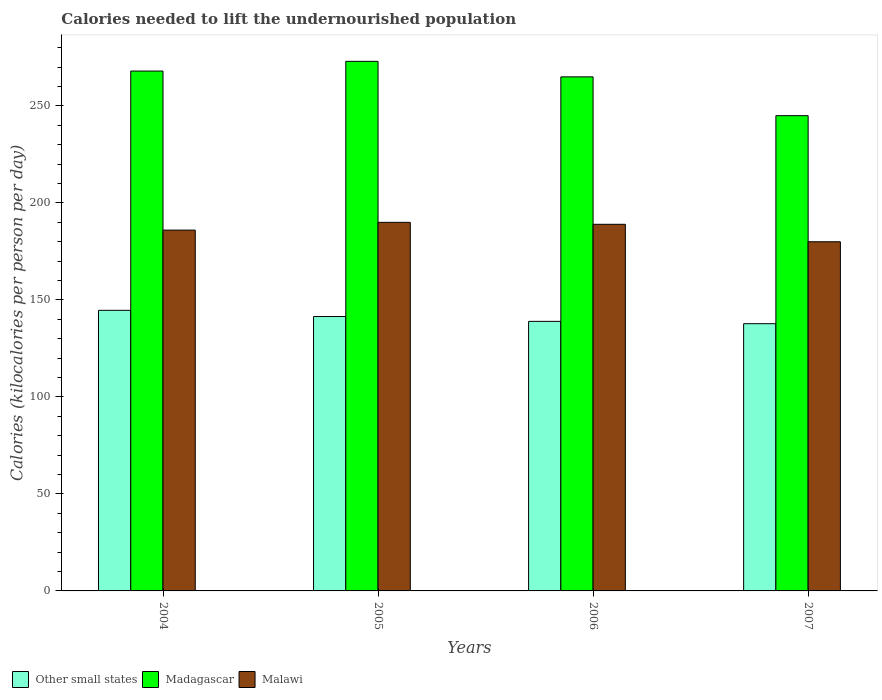What is the label of the 1st group of bars from the left?
Your response must be concise. 2004. What is the total calories needed to lift the undernourished population in Malawi in 2007?
Your response must be concise. 180. Across all years, what is the maximum total calories needed to lift the undernourished population in Other small states?
Keep it short and to the point. 144.65. Across all years, what is the minimum total calories needed to lift the undernourished population in Other small states?
Your answer should be very brief. 137.76. In which year was the total calories needed to lift the undernourished population in Madagascar maximum?
Provide a succinct answer. 2005. What is the total total calories needed to lift the undernourished population in Other small states in the graph?
Make the answer very short. 562.81. What is the difference between the total calories needed to lift the undernourished population in Other small states in 2005 and that in 2007?
Ensure brevity in your answer.  3.69. What is the difference between the total calories needed to lift the undernourished population in Madagascar in 2007 and the total calories needed to lift the undernourished population in Other small states in 2005?
Keep it short and to the point. 103.55. What is the average total calories needed to lift the undernourished population in Madagascar per year?
Provide a short and direct response. 262.75. In the year 2006, what is the difference between the total calories needed to lift the undernourished population in Madagascar and total calories needed to lift the undernourished population in Malawi?
Provide a short and direct response. 76. What is the ratio of the total calories needed to lift the undernourished population in Other small states in 2005 to that in 2006?
Your answer should be compact. 1.02. Is the total calories needed to lift the undernourished population in Other small states in 2004 less than that in 2006?
Offer a terse response. No. What is the difference between the highest and the second highest total calories needed to lift the undernourished population in Malawi?
Ensure brevity in your answer.  1. What is the difference between the highest and the lowest total calories needed to lift the undernourished population in Other small states?
Your response must be concise. 6.88. Is the sum of the total calories needed to lift the undernourished population in Other small states in 2005 and 2007 greater than the maximum total calories needed to lift the undernourished population in Madagascar across all years?
Your answer should be very brief. Yes. What does the 1st bar from the left in 2007 represents?
Your answer should be compact. Other small states. What does the 3rd bar from the right in 2006 represents?
Keep it short and to the point. Other small states. Are all the bars in the graph horizontal?
Provide a short and direct response. No. Does the graph contain any zero values?
Your answer should be compact. No. Where does the legend appear in the graph?
Keep it short and to the point. Bottom left. How many legend labels are there?
Ensure brevity in your answer.  3. How are the legend labels stacked?
Offer a terse response. Horizontal. What is the title of the graph?
Give a very brief answer. Calories needed to lift the undernourished population. What is the label or title of the X-axis?
Your response must be concise. Years. What is the label or title of the Y-axis?
Keep it short and to the point. Calories (kilocalories per person per day). What is the Calories (kilocalories per person per day) of Other small states in 2004?
Give a very brief answer. 144.65. What is the Calories (kilocalories per person per day) in Madagascar in 2004?
Provide a short and direct response. 268. What is the Calories (kilocalories per person per day) of Malawi in 2004?
Your answer should be very brief. 186. What is the Calories (kilocalories per person per day) in Other small states in 2005?
Offer a terse response. 141.45. What is the Calories (kilocalories per person per day) of Madagascar in 2005?
Give a very brief answer. 273. What is the Calories (kilocalories per person per day) of Malawi in 2005?
Ensure brevity in your answer.  190. What is the Calories (kilocalories per person per day) in Other small states in 2006?
Ensure brevity in your answer.  138.96. What is the Calories (kilocalories per person per day) in Madagascar in 2006?
Your answer should be very brief. 265. What is the Calories (kilocalories per person per day) of Malawi in 2006?
Your answer should be compact. 189. What is the Calories (kilocalories per person per day) of Other small states in 2007?
Make the answer very short. 137.76. What is the Calories (kilocalories per person per day) in Madagascar in 2007?
Your answer should be very brief. 245. What is the Calories (kilocalories per person per day) in Malawi in 2007?
Make the answer very short. 180. Across all years, what is the maximum Calories (kilocalories per person per day) in Other small states?
Your response must be concise. 144.65. Across all years, what is the maximum Calories (kilocalories per person per day) of Madagascar?
Your response must be concise. 273. Across all years, what is the maximum Calories (kilocalories per person per day) of Malawi?
Offer a terse response. 190. Across all years, what is the minimum Calories (kilocalories per person per day) of Other small states?
Give a very brief answer. 137.76. Across all years, what is the minimum Calories (kilocalories per person per day) of Madagascar?
Provide a short and direct response. 245. Across all years, what is the minimum Calories (kilocalories per person per day) of Malawi?
Provide a short and direct response. 180. What is the total Calories (kilocalories per person per day) of Other small states in the graph?
Your response must be concise. 562.81. What is the total Calories (kilocalories per person per day) in Madagascar in the graph?
Offer a very short reply. 1051. What is the total Calories (kilocalories per person per day) of Malawi in the graph?
Offer a very short reply. 745. What is the difference between the Calories (kilocalories per person per day) in Other small states in 2004 and that in 2005?
Give a very brief answer. 3.2. What is the difference between the Calories (kilocalories per person per day) of Madagascar in 2004 and that in 2005?
Make the answer very short. -5. What is the difference between the Calories (kilocalories per person per day) of Other small states in 2004 and that in 2006?
Offer a terse response. 5.69. What is the difference between the Calories (kilocalories per person per day) in Other small states in 2004 and that in 2007?
Make the answer very short. 6.88. What is the difference between the Calories (kilocalories per person per day) in Madagascar in 2004 and that in 2007?
Give a very brief answer. 23. What is the difference between the Calories (kilocalories per person per day) of Malawi in 2004 and that in 2007?
Your answer should be compact. 6. What is the difference between the Calories (kilocalories per person per day) of Other small states in 2005 and that in 2006?
Offer a terse response. 2.49. What is the difference between the Calories (kilocalories per person per day) in Madagascar in 2005 and that in 2006?
Offer a very short reply. 8. What is the difference between the Calories (kilocalories per person per day) in Other small states in 2005 and that in 2007?
Your response must be concise. 3.69. What is the difference between the Calories (kilocalories per person per day) of Malawi in 2005 and that in 2007?
Your response must be concise. 10. What is the difference between the Calories (kilocalories per person per day) in Other small states in 2006 and that in 2007?
Keep it short and to the point. 1.19. What is the difference between the Calories (kilocalories per person per day) in Madagascar in 2006 and that in 2007?
Provide a short and direct response. 20. What is the difference between the Calories (kilocalories per person per day) of Malawi in 2006 and that in 2007?
Keep it short and to the point. 9. What is the difference between the Calories (kilocalories per person per day) of Other small states in 2004 and the Calories (kilocalories per person per day) of Madagascar in 2005?
Give a very brief answer. -128.35. What is the difference between the Calories (kilocalories per person per day) of Other small states in 2004 and the Calories (kilocalories per person per day) of Malawi in 2005?
Offer a very short reply. -45.35. What is the difference between the Calories (kilocalories per person per day) in Madagascar in 2004 and the Calories (kilocalories per person per day) in Malawi in 2005?
Your answer should be compact. 78. What is the difference between the Calories (kilocalories per person per day) of Other small states in 2004 and the Calories (kilocalories per person per day) of Madagascar in 2006?
Your answer should be very brief. -120.35. What is the difference between the Calories (kilocalories per person per day) in Other small states in 2004 and the Calories (kilocalories per person per day) in Malawi in 2006?
Your answer should be very brief. -44.35. What is the difference between the Calories (kilocalories per person per day) in Madagascar in 2004 and the Calories (kilocalories per person per day) in Malawi in 2006?
Give a very brief answer. 79. What is the difference between the Calories (kilocalories per person per day) in Other small states in 2004 and the Calories (kilocalories per person per day) in Madagascar in 2007?
Ensure brevity in your answer.  -100.35. What is the difference between the Calories (kilocalories per person per day) in Other small states in 2004 and the Calories (kilocalories per person per day) in Malawi in 2007?
Your answer should be compact. -35.35. What is the difference between the Calories (kilocalories per person per day) in Other small states in 2005 and the Calories (kilocalories per person per day) in Madagascar in 2006?
Provide a short and direct response. -123.55. What is the difference between the Calories (kilocalories per person per day) in Other small states in 2005 and the Calories (kilocalories per person per day) in Malawi in 2006?
Make the answer very short. -47.55. What is the difference between the Calories (kilocalories per person per day) in Other small states in 2005 and the Calories (kilocalories per person per day) in Madagascar in 2007?
Your answer should be compact. -103.55. What is the difference between the Calories (kilocalories per person per day) in Other small states in 2005 and the Calories (kilocalories per person per day) in Malawi in 2007?
Ensure brevity in your answer.  -38.55. What is the difference between the Calories (kilocalories per person per day) in Madagascar in 2005 and the Calories (kilocalories per person per day) in Malawi in 2007?
Keep it short and to the point. 93. What is the difference between the Calories (kilocalories per person per day) of Other small states in 2006 and the Calories (kilocalories per person per day) of Madagascar in 2007?
Your response must be concise. -106.04. What is the difference between the Calories (kilocalories per person per day) in Other small states in 2006 and the Calories (kilocalories per person per day) in Malawi in 2007?
Keep it short and to the point. -41.04. What is the average Calories (kilocalories per person per day) in Other small states per year?
Offer a terse response. 140.7. What is the average Calories (kilocalories per person per day) of Madagascar per year?
Make the answer very short. 262.75. What is the average Calories (kilocalories per person per day) in Malawi per year?
Provide a short and direct response. 186.25. In the year 2004, what is the difference between the Calories (kilocalories per person per day) in Other small states and Calories (kilocalories per person per day) in Madagascar?
Provide a short and direct response. -123.35. In the year 2004, what is the difference between the Calories (kilocalories per person per day) in Other small states and Calories (kilocalories per person per day) in Malawi?
Offer a terse response. -41.35. In the year 2004, what is the difference between the Calories (kilocalories per person per day) in Madagascar and Calories (kilocalories per person per day) in Malawi?
Provide a short and direct response. 82. In the year 2005, what is the difference between the Calories (kilocalories per person per day) of Other small states and Calories (kilocalories per person per day) of Madagascar?
Ensure brevity in your answer.  -131.55. In the year 2005, what is the difference between the Calories (kilocalories per person per day) in Other small states and Calories (kilocalories per person per day) in Malawi?
Provide a short and direct response. -48.55. In the year 2005, what is the difference between the Calories (kilocalories per person per day) of Madagascar and Calories (kilocalories per person per day) of Malawi?
Offer a very short reply. 83. In the year 2006, what is the difference between the Calories (kilocalories per person per day) of Other small states and Calories (kilocalories per person per day) of Madagascar?
Offer a very short reply. -126.04. In the year 2006, what is the difference between the Calories (kilocalories per person per day) of Other small states and Calories (kilocalories per person per day) of Malawi?
Your response must be concise. -50.04. In the year 2006, what is the difference between the Calories (kilocalories per person per day) in Madagascar and Calories (kilocalories per person per day) in Malawi?
Provide a succinct answer. 76. In the year 2007, what is the difference between the Calories (kilocalories per person per day) of Other small states and Calories (kilocalories per person per day) of Madagascar?
Give a very brief answer. -107.24. In the year 2007, what is the difference between the Calories (kilocalories per person per day) of Other small states and Calories (kilocalories per person per day) of Malawi?
Make the answer very short. -42.24. What is the ratio of the Calories (kilocalories per person per day) of Other small states in 2004 to that in 2005?
Your answer should be very brief. 1.02. What is the ratio of the Calories (kilocalories per person per day) of Madagascar in 2004 to that in 2005?
Keep it short and to the point. 0.98. What is the ratio of the Calories (kilocalories per person per day) in Malawi in 2004 to that in 2005?
Make the answer very short. 0.98. What is the ratio of the Calories (kilocalories per person per day) in Other small states in 2004 to that in 2006?
Your answer should be very brief. 1.04. What is the ratio of the Calories (kilocalories per person per day) of Madagascar in 2004 to that in 2006?
Provide a short and direct response. 1.01. What is the ratio of the Calories (kilocalories per person per day) in Malawi in 2004 to that in 2006?
Offer a terse response. 0.98. What is the ratio of the Calories (kilocalories per person per day) in Madagascar in 2004 to that in 2007?
Give a very brief answer. 1.09. What is the ratio of the Calories (kilocalories per person per day) in Malawi in 2004 to that in 2007?
Provide a succinct answer. 1.03. What is the ratio of the Calories (kilocalories per person per day) of Other small states in 2005 to that in 2006?
Your answer should be very brief. 1.02. What is the ratio of the Calories (kilocalories per person per day) in Madagascar in 2005 to that in 2006?
Your answer should be very brief. 1.03. What is the ratio of the Calories (kilocalories per person per day) of Other small states in 2005 to that in 2007?
Your answer should be very brief. 1.03. What is the ratio of the Calories (kilocalories per person per day) in Madagascar in 2005 to that in 2007?
Your response must be concise. 1.11. What is the ratio of the Calories (kilocalories per person per day) of Malawi in 2005 to that in 2007?
Offer a very short reply. 1.06. What is the ratio of the Calories (kilocalories per person per day) in Other small states in 2006 to that in 2007?
Ensure brevity in your answer.  1.01. What is the ratio of the Calories (kilocalories per person per day) of Madagascar in 2006 to that in 2007?
Give a very brief answer. 1.08. What is the difference between the highest and the second highest Calories (kilocalories per person per day) of Other small states?
Your answer should be very brief. 3.2. What is the difference between the highest and the lowest Calories (kilocalories per person per day) in Other small states?
Offer a terse response. 6.88. What is the difference between the highest and the lowest Calories (kilocalories per person per day) of Madagascar?
Your answer should be compact. 28. 